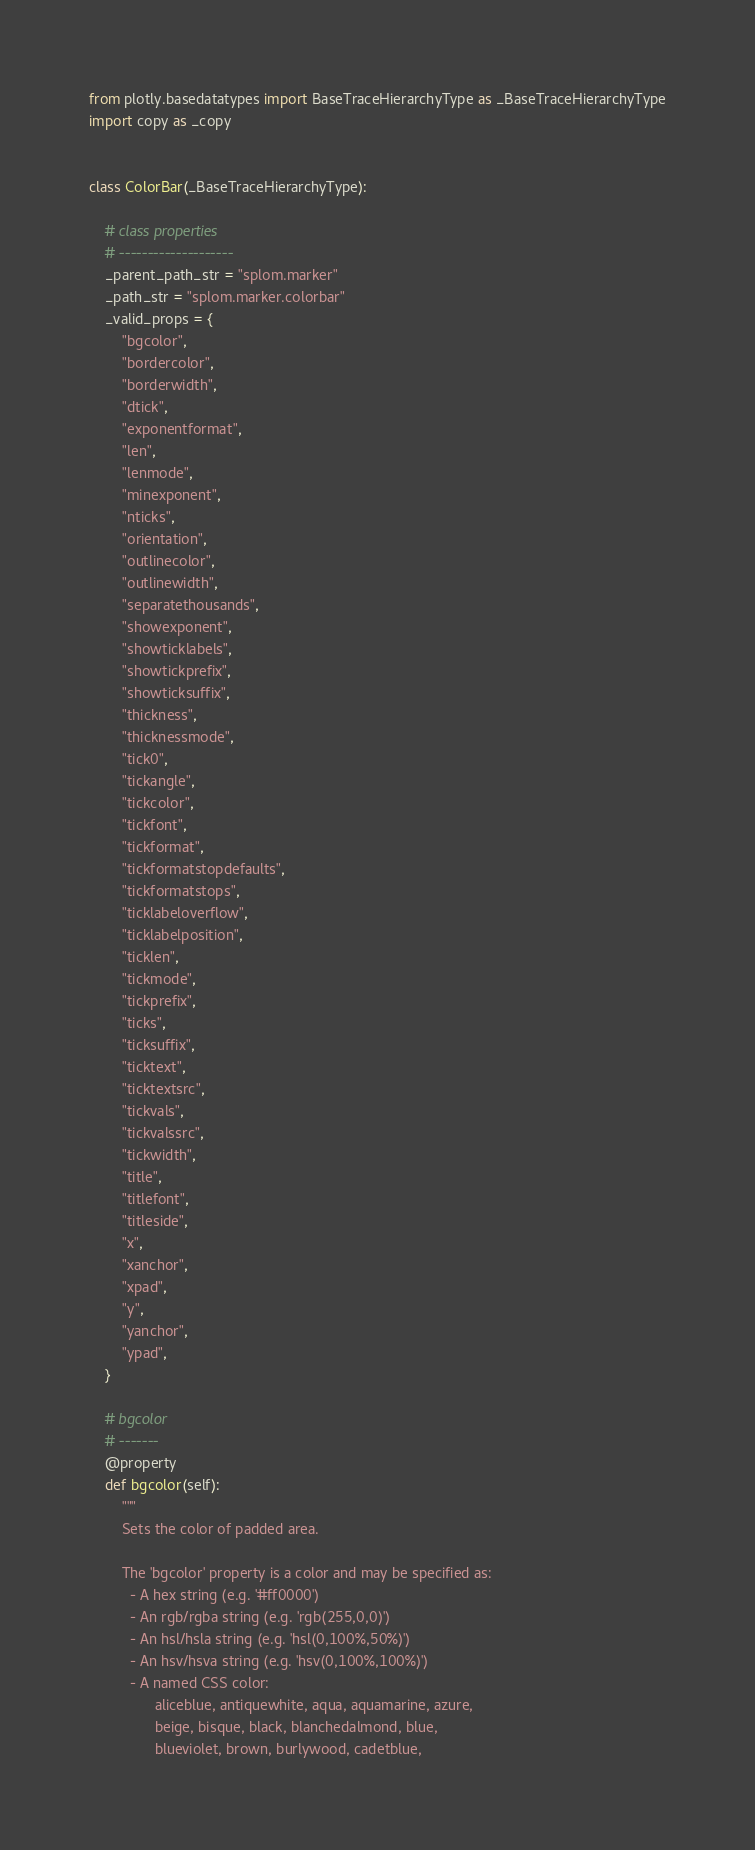<code> <loc_0><loc_0><loc_500><loc_500><_Python_>from plotly.basedatatypes import BaseTraceHierarchyType as _BaseTraceHierarchyType
import copy as _copy


class ColorBar(_BaseTraceHierarchyType):

    # class properties
    # --------------------
    _parent_path_str = "splom.marker"
    _path_str = "splom.marker.colorbar"
    _valid_props = {
        "bgcolor",
        "bordercolor",
        "borderwidth",
        "dtick",
        "exponentformat",
        "len",
        "lenmode",
        "minexponent",
        "nticks",
        "orientation",
        "outlinecolor",
        "outlinewidth",
        "separatethousands",
        "showexponent",
        "showticklabels",
        "showtickprefix",
        "showticksuffix",
        "thickness",
        "thicknessmode",
        "tick0",
        "tickangle",
        "tickcolor",
        "tickfont",
        "tickformat",
        "tickformatstopdefaults",
        "tickformatstops",
        "ticklabeloverflow",
        "ticklabelposition",
        "ticklen",
        "tickmode",
        "tickprefix",
        "ticks",
        "ticksuffix",
        "ticktext",
        "ticktextsrc",
        "tickvals",
        "tickvalssrc",
        "tickwidth",
        "title",
        "titlefont",
        "titleside",
        "x",
        "xanchor",
        "xpad",
        "y",
        "yanchor",
        "ypad",
    }

    # bgcolor
    # -------
    @property
    def bgcolor(self):
        """
        Sets the color of padded area.
    
        The 'bgcolor' property is a color and may be specified as:
          - A hex string (e.g. '#ff0000')
          - An rgb/rgba string (e.g. 'rgb(255,0,0)')
          - An hsl/hsla string (e.g. 'hsl(0,100%,50%)')
          - An hsv/hsva string (e.g. 'hsv(0,100%,100%)')
          - A named CSS color:
                aliceblue, antiquewhite, aqua, aquamarine, azure,
                beige, bisque, black, blanchedalmond, blue,
                blueviolet, brown, burlywood, cadetblue,</code> 